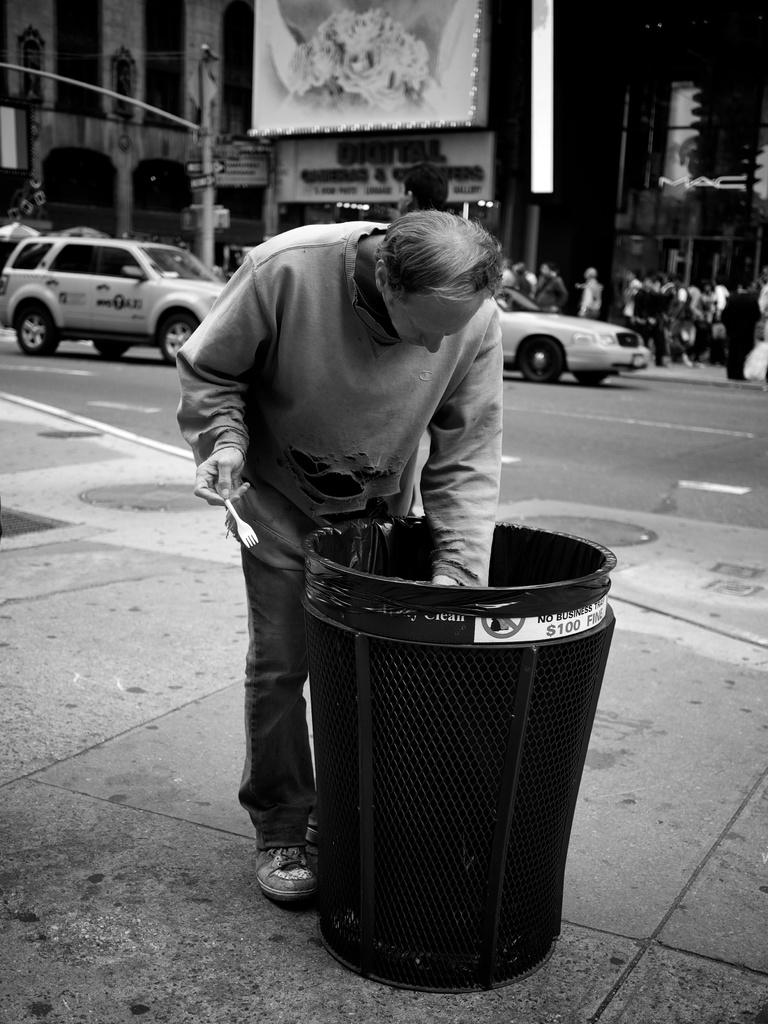<image>
Relay a brief, clear account of the picture shown. A man digs in a garbage can that says no business garbage on it. 